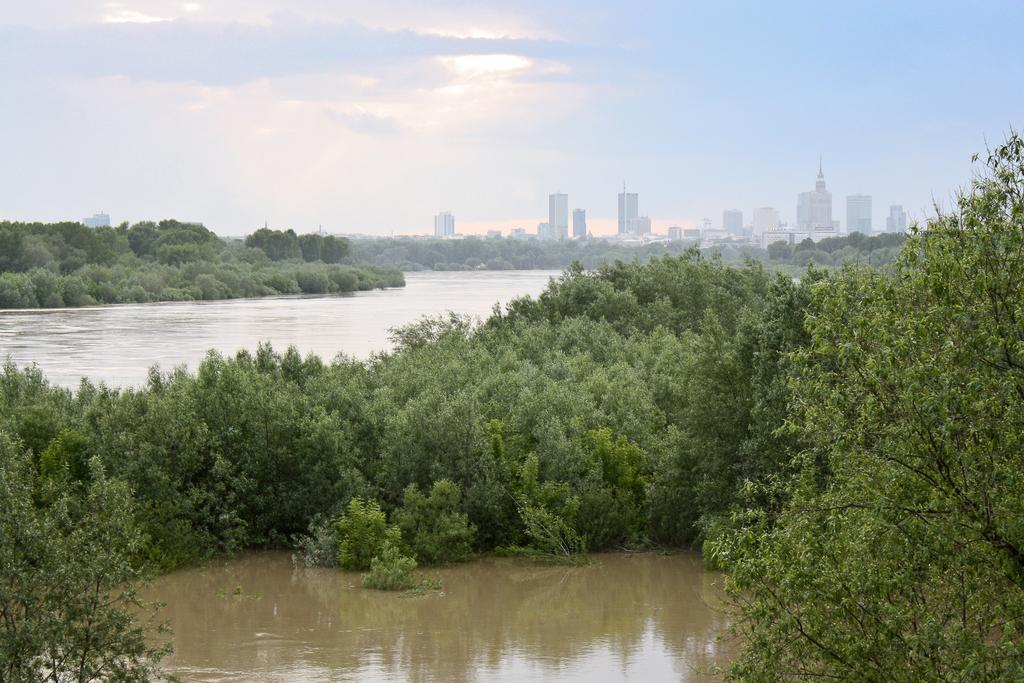What is visible at the bottom of the image? There is water visible at the bottom of the image. What can be seen in the image besides the water at the bottom? There are trees in the image. What is visible in the background of the image? In the background, there is water, trees, buildings, poles, and clouds visible. Can you see a kitty playing with a wrench in the image? There is no kitty or wrench present in the image. What type of beast is hiding behind the trees in the background? There is no beast present in the image; only trees, water, buildings, poles, and clouds are visible in the background. 